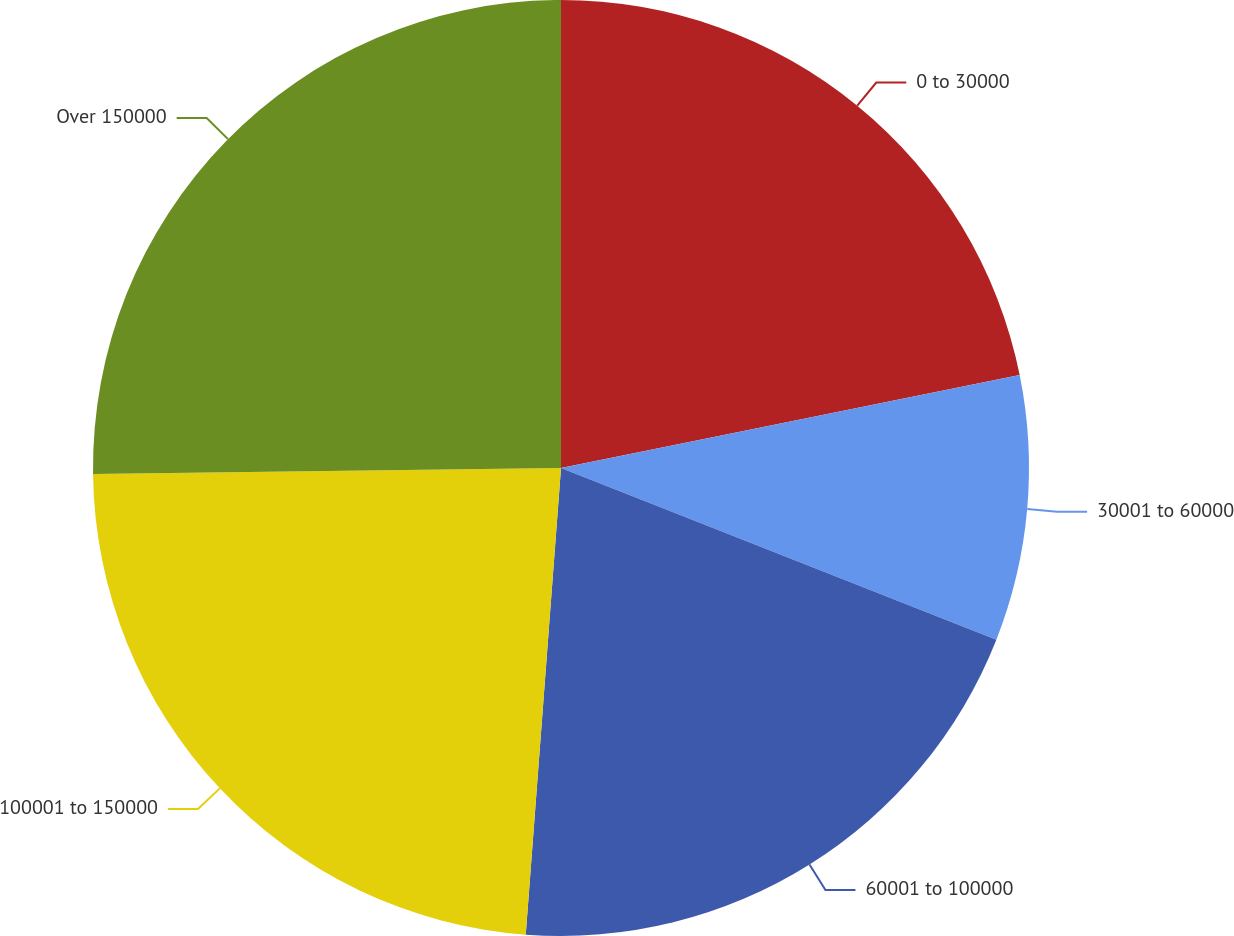Convert chart to OTSL. <chart><loc_0><loc_0><loc_500><loc_500><pie_chart><fcel>0 to 30000<fcel>30001 to 60000<fcel>60001 to 100000<fcel>100001 to 150000<fcel>Over 150000<nl><fcel>21.82%<fcel>9.16%<fcel>20.22%<fcel>23.6%<fcel>25.2%<nl></chart> 